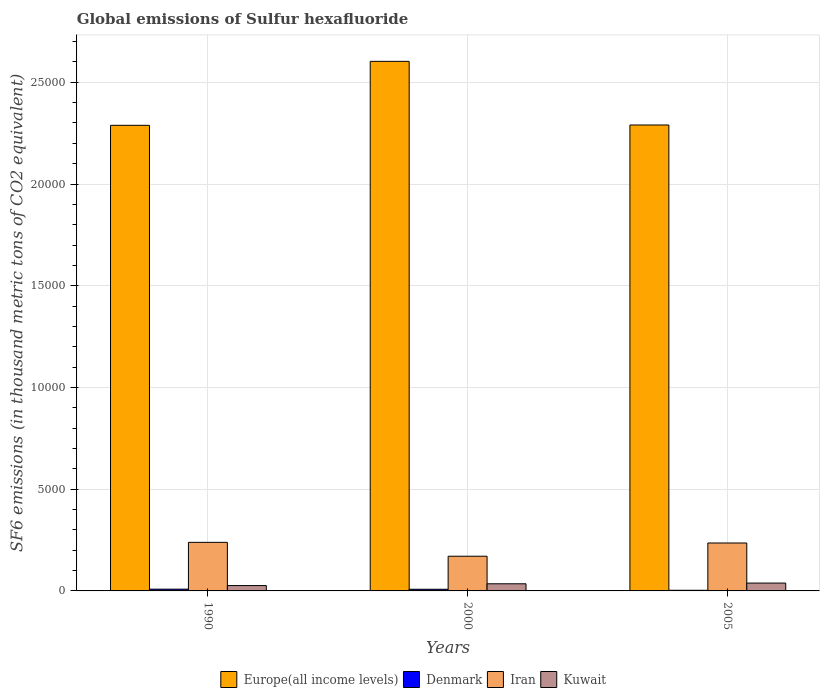Are the number of bars per tick equal to the number of legend labels?
Give a very brief answer. Yes. What is the global emissions of Sulfur hexafluoride in Iran in 1990?
Your answer should be compact. 2387.3. Across all years, what is the maximum global emissions of Sulfur hexafluoride in Europe(all income levels)?
Your answer should be compact. 2.60e+04. Across all years, what is the minimum global emissions of Sulfur hexafluoride in Denmark?
Your answer should be compact. 31.5. In which year was the global emissions of Sulfur hexafluoride in Denmark minimum?
Offer a terse response. 2005. What is the total global emissions of Sulfur hexafluoride in Denmark in the graph?
Provide a succinct answer. 199.6. What is the difference between the global emissions of Sulfur hexafluoride in Denmark in 1990 and that in 2005?
Keep it short and to the point. 55.2. What is the difference between the global emissions of Sulfur hexafluoride in Kuwait in 2000 and the global emissions of Sulfur hexafluoride in Iran in 1990?
Make the answer very short. -2036.4. What is the average global emissions of Sulfur hexafluoride in Iran per year?
Your response must be concise. 2149.23. In the year 2000, what is the difference between the global emissions of Sulfur hexafluoride in Kuwait and global emissions of Sulfur hexafluoride in Iran?
Provide a short and direct response. -1354. In how many years, is the global emissions of Sulfur hexafluoride in Europe(all income levels) greater than 7000 thousand metric tons?
Provide a succinct answer. 3. What is the ratio of the global emissions of Sulfur hexafluoride in Denmark in 2000 to that in 2005?
Provide a short and direct response. 2.58. Is the global emissions of Sulfur hexafluoride in Denmark in 2000 less than that in 2005?
Offer a very short reply. No. Is the difference between the global emissions of Sulfur hexafluoride in Kuwait in 2000 and 2005 greater than the difference between the global emissions of Sulfur hexafluoride in Iran in 2000 and 2005?
Provide a short and direct response. Yes. What is the difference between the highest and the second highest global emissions of Sulfur hexafluoride in Iran?
Give a very brief answer. 31.8. What is the difference between the highest and the lowest global emissions of Sulfur hexafluoride in Europe(all income levels)?
Offer a terse response. 3144.4. In how many years, is the global emissions of Sulfur hexafluoride in Iran greater than the average global emissions of Sulfur hexafluoride in Iran taken over all years?
Offer a terse response. 2. Is the sum of the global emissions of Sulfur hexafluoride in Iran in 1990 and 2000 greater than the maximum global emissions of Sulfur hexafluoride in Kuwait across all years?
Make the answer very short. Yes. What does the 2nd bar from the right in 2000 represents?
Your response must be concise. Iran. Is it the case that in every year, the sum of the global emissions of Sulfur hexafluoride in Kuwait and global emissions of Sulfur hexafluoride in Iran is greater than the global emissions of Sulfur hexafluoride in Europe(all income levels)?
Ensure brevity in your answer.  No. Are all the bars in the graph horizontal?
Make the answer very short. No. How many years are there in the graph?
Provide a short and direct response. 3. What is the difference between two consecutive major ticks on the Y-axis?
Keep it short and to the point. 5000. Are the values on the major ticks of Y-axis written in scientific E-notation?
Provide a short and direct response. No. Does the graph contain any zero values?
Ensure brevity in your answer.  No. How are the legend labels stacked?
Ensure brevity in your answer.  Horizontal. What is the title of the graph?
Ensure brevity in your answer.  Global emissions of Sulfur hexafluoride. Does "Middle East & North Africa (developing only)" appear as one of the legend labels in the graph?
Ensure brevity in your answer.  No. What is the label or title of the X-axis?
Provide a short and direct response. Years. What is the label or title of the Y-axis?
Your answer should be compact. SF6 emissions (in thousand metric tons of CO2 equivalent). What is the SF6 emissions (in thousand metric tons of CO2 equivalent) in Europe(all income levels) in 1990?
Ensure brevity in your answer.  2.29e+04. What is the SF6 emissions (in thousand metric tons of CO2 equivalent) of Denmark in 1990?
Provide a short and direct response. 86.7. What is the SF6 emissions (in thousand metric tons of CO2 equivalent) in Iran in 1990?
Give a very brief answer. 2387.3. What is the SF6 emissions (in thousand metric tons of CO2 equivalent) of Kuwait in 1990?
Give a very brief answer. 263. What is the SF6 emissions (in thousand metric tons of CO2 equivalent) in Europe(all income levels) in 2000?
Make the answer very short. 2.60e+04. What is the SF6 emissions (in thousand metric tons of CO2 equivalent) in Denmark in 2000?
Provide a short and direct response. 81.4. What is the SF6 emissions (in thousand metric tons of CO2 equivalent) of Iran in 2000?
Provide a succinct answer. 1704.9. What is the SF6 emissions (in thousand metric tons of CO2 equivalent) of Kuwait in 2000?
Give a very brief answer. 350.9. What is the SF6 emissions (in thousand metric tons of CO2 equivalent) of Europe(all income levels) in 2005?
Ensure brevity in your answer.  2.29e+04. What is the SF6 emissions (in thousand metric tons of CO2 equivalent) in Denmark in 2005?
Your answer should be very brief. 31.5. What is the SF6 emissions (in thousand metric tons of CO2 equivalent) of Iran in 2005?
Your answer should be compact. 2355.5. What is the SF6 emissions (in thousand metric tons of CO2 equivalent) in Kuwait in 2005?
Make the answer very short. 386. Across all years, what is the maximum SF6 emissions (in thousand metric tons of CO2 equivalent) of Europe(all income levels)?
Your response must be concise. 2.60e+04. Across all years, what is the maximum SF6 emissions (in thousand metric tons of CO2 equivalent) of Denmark?
Your answer should be compact. 86.7. Across all years, what is the maximum SF6 emissions (in thousand metric tons of CO2 equivalent) in Iran?
Offer a very short reply. 2387.3. Across all years, what is the maximum SF6 emissions (in thousand metric tons of CO2 equivalent) of Kuwait?
Provide a short and direct response. 386. Across all years, what is the minimum SF6 emissions (in thousand metric tons of CO2 equivalent) of Europe(all income levels)?
Provide a short and direct response. 2.29e+04. Across all years, what is the minimum SF6 emissions (in thousand metric tons of CO2 equivalent) of Denmark?
Provide a short and direct response. 31.5. Across all years, what is the minimum SF6 emissions (in thousand metric tons of CO2 equivalent) in Iran?
Your response must be concise. 1704.9. Across all years, what is the minimum SF6 emissions (in thousand metric tons of CO2 equivalent) in Kuwait?
Make the answer very short. 263. What is the total SF6 emissions (in thousand metric tons of CO2 equivalent) of Europe(all income levels) in the graph?
Offer a terse response. 7.18e+04. What is the total SF6 emissions (in thousand metric tons of CO2 equivalent) in Denmark in the graph?
Keep it short and to the point. 199.6. What is the total SF6 emissions (in thousand metric tons of CO2 equivalent) of Iran in the graph?
Give a very brief answer. 6447.7. What is the total SF6 emissions (in thousand metric tons of CO2 equivalent) of Kuwait in the graph?
Your response must be concise. 999.9. What is the difference between the SF6 emissions (in thousand metric tons of CO2 equivalent) of Europe(all income levels) in 1990 and that in 2000?
Provide a short and direct response. -3144.4. What is the difference between the SF6 emissions (in thousand metric tons of CO2 equivalent) of Denmark in 1990 and that in 2000?
Offer a very short reply. 5.3. What is the difference between the SF6 emissions (in thousand metric tons of CO2 equivalent) of Iran in 1990 and that in 2000?
Ensure brevity in your answer.  682.4. What is the difference between the SF6 emissions (in thousand metric tons of CO2 equivalent) of Kuwait in 1990 and that in 2000?
Offer a very short reply. -87.9. What is the difference between the SF6 emissions (in thousand metric tons of CO2 equivalent) of Europe(all income levels) in 1990 and that in 2005?
Your response must be concise. -16.51. What is the difference between the SF6 emissions (in thousand metric tons of CO2 equivalent) in Denmark in 1990 and that in 2005?
Give a very brief answer. 55.2. What is the difference between the SF6 emissions (in thousand metric tons of CO2 equivalent) in Iran in 1990 and that in 2005?
Your answer should be very brief. 31.8. What is the difference between the SF6 emissions (in thousand metric tons of CO2 equivalent) of Kuwait in 1990 and that in 2005?
Offer a terse response. -123. What is the difference between the SF6 emissions (in thousand metric tons of CO2 equivalent) of Europe(all income levels) in 2000 and that in 2005?
Ensure brevity in your answer.  3127.89. What is the difference between the SF6 emissions (in thousand metric tons of CO2 equivalent) of Denmark in 2000 and that in 2005?
Offer a very short reply. 49.9. What is the difference between the SF6 emissions (in thousand metric tons of CO2 equivalent) of Iran in 2000 and that in 2005?
Your answer should be compact. -650.6. What is the difference between the SF6 emissions (in thousand metric tons of CO2 equivalent) in Kuwait in 2000 and that in 2005?
Give a very brief answer. -35.1. What is the difference between the SF6 emissions (in thousand metric tons of CO2 equivalent) of Europe(all income levels) in 1990 and the SF6 emissions (in thousand metric tons of CO2 equivalent) of Denmark in 2000?
Your answer should be compact. 2.28e+04. What is the difference between the SF6 emissions (in thousand metric tons of CO2 equivalent) of Europe(all income levels) in 1990 and the SF6 emissions (in thousand metric tons of CO2 equivalent) of Iran in 2000?
Offer a very short reply. 2.12e+04. What is the difference between the SF6 emissions (in thousand metric tons of CO2 equivalent) of Europe(all income levels) in 1990 and the SF6 emissions (in thousand metric tons of CO2 equivalent) of Kuwait in 2000?
Your response must be concise. 2.25e+04. What is the difference between the SF6 emissions (in thousand metric tons of CO2 equivalent) of Denmark in 1990 and the SF6 emissions (in thousand metric tons of CO2 equivalent) of Iran in 2000?
Your response must be concise. -1618.2. What is the difference between the SF6 emissions (in thousand metric tons of CO2 equivalent) in Denmark in 1990 and the SF6 emissions (in thousand metric tons of CO2 equivalent) in Kuwait in 2000?
Give a very brief answer. -264.2. What is the difference between the SF6 emissions (in thousand metric tons of CO2 equivalent) of Iran in 1990 and the SF6 emissions (in thousand metric tons of CO2 equivalent) of Kuwait in 2000?
Offer a terse response. 2036.4. What is the difference between the SF6 emissions (in thousand metric tons of CO2 equivalent) of Europe(all income levels) in 1990 and the SF6 emissions (in thousand metric tons of CO2 equivalent) of Denmark in 2005?
Give a very brief answer. 2.29e+04. What is the difference between the SF6 emissions (in thousand metric tons of CO2 equivalent) of Europe(all income levels) in 1990 and the SF6 emissions (in thousand metric tons of CO2 equivalent) of Iran in 2005?
Your answer should be very brief. 2.05e+04. What is the difference between the SF6 emissions (in thousand metric tons of CO2 equivalent) in Europe(all income levels) in 1990 and the SF6 emissions (in thousand metric tons of CO2 equivalent) in Kuwait in 2005?
Provide a short and direct response. 2.25e+04. What is the difference between the SF6 emissions (in thousand metric tons of CO2 equivalent) of Denmark in 1990 and the SF6 emissions (in thousand metric tons of CO2 equivalent) of Iran in 2005?
Keep it short and to the point. -2268.8. What is the difference between the SF6 emissions (in thousand metric tons of CO2 equivalent) in Denmark in 1990 and the SF6 emissions (in thousand metric tons of CO2 equivalent) in Kuwait in 2005?
Ensure brevity in your answer.  -299.3. What is the difference between the SF6 emissions (in thousand metric tons of CO2 equivalent) in Iran in 1990 and the SF6 emissions (in thousand metric tons of CO2 equivalent) in Kuwait in 2005?
Keep it short and to the point. 2001.3. What is the difference between the SF6 emissions (in thousand metric tons of CO2 equivalent) of Europe(all income levels) in 2000 and the SF6 emissions (in thousand metric tons of CO2 equivalent) of Denmark in 2005?
Your answer should be compact. 2.60e+04. What is the difference between the SF6 emissions (in thousand metric tons of CO2 equivalent) in Europe(all income levels) in 2000 and the SF6 emissions (in thousand metric tons of CO2 equivalent) in Iran in 2005?
Your answer should be very brief. 2.37e+04. What is the difference between the SF6 emissions (in thousand metric tons of CO2 equivalent) of Europe(all income levels) in 2000 and the SF6 emissions (in thousand metric tons of CO2 equivalent) of Kuwait in 2005?
Your answer should be compact. 2.56e+04. What is the difference between the SF6 emissions (in thousand metric tons of CO2 equivalent) of Denmark in 2000 and the SF6 emissions (in thousand metric tons of CO2 equivalent) of Iran in 2005?
Your response must be concise. -2274.1. What is the difference between the SF6 emissions (in thousand metric tons of CO2 equivalent) in Denmark in 2000 and the SF6 emissions (in thousand metric tons of CO2 equivalent) in Kuwait in 2005?
Your response must be concise. -304.6. What is the difference between the SF6 emissions (in thousand metric tons of CO2 equivalent) in Iran in 2000 and the SF6 emissions (in thousand metric tons of CO2 equivalent) in Kuwait in 2005?
Your answer should be compact. 1318.9. What is the average SF6 emissions (in thousand metric tons of CO2 equivalent) in Europe(all income levels) per year?
Your answer should be very brief. 2.39e+04. What is the average SF6 emissions (in thousand metric tons of CO2 equivalent) in Denmark per year?
Offer a terse response. 66.53. What is the average SF6 emissions (in thousand metric tons of CO2 equivalent) of Iran per year?
Keep it short and to the point. 2149.23. What is the average SF6 emissions (in thousand metric tons of CO2 equivalent) in Kuwait per year?
Your answer should be compact. 333.3. In the year 1990, what is the difference between the SF6 emissions (in thousand metric tons of CO2 equivalent) in Europe(all income levels) and SF6 emissions (in thousand metric tons of CO2 equivalent) in Denmark?
Provide a short and direct response. 2.28e+04. In the year 1990, what is the difference between the SF6 emissions (in thousand metric tons of CO2 equivalent) in Europe(all income levels) and SF6 emissions (in thousand metric tons of CO2 equivalent) in Iran?
Your response must be concise. 2.05e+04. In the year 1990, what is the difference between the SF6 emissions (in thousand metric tons of CO2 equivalent) in Europe(all income levels) and SF6 emissions (in thousand metric tons of CO2 equivalent) in Kuwait?
Make the answer very short. 2.26e+04. In the year 1990, what is the difference between the SF6 emissions (in thousand metric tons of CO2 equivalent) in Denmark and SF6 emissions (in thousand metric tons of CO2 equivalent) in Iran?
Your answer should be compact. -2300.6. In the year 1990, what is the difference between the SF6 emissions (in thousand metric tons of CO2 equivalent) in Denmark and SF6 emissions (in thousand metric tons of CO2 equivalent) in Kuwait?
Keep it short and to the point. -176.3. In the year 1990, what is the difference between the SF6 emissions (in thousand metric tons of CO2 equivalent) in Iran and SF6 emissions (in thousand metric tons of CO2 equivalent) in Kuwait?
Ensure brevity in your answer.  2124.3. In the year 2000, what is the difference between the SF6 emissions (in thousand metric tons of CO2 equivalent) in Europe(all income levels) and SF6 emissions (in thousand metric tons of CO2 equivalent) in Denmark?
Your response must be concise. 2.59e+04. In the year 2000, what is the difference between the SF6 emissions (in thousand metric tons of CO2 equivalent) in Europe(all income levels) and SF6 emissions (in thousand metric tons of CO2 equivalent) in Iran?
Keep it short and to the point. 2.43e+04. In the year 2000, what is the difference between the SF6 emissions (in thousand metric tons of CO2 equivalent) in Europe(all income levels) and SF6 emissions (in thousand metric tons of CO2 equivalent) in Kuwait?
Provide a short and direct response. 2.57e+04. In the year 2000, what is the difference between the SF6 emissions (in thousand metric tons of CO2 equivalent) in Denmark and SF6 emissions (in thousand metric tons of CO2 equivalent) in Iran?
Keep it short and to the point. -1623.5. In the year 2000, what is the difference between the SF6 emissions (in thousand metric tons of CO2 equivalent) in Denmark and SF6 emissions (in thousand metric tons of CO2 equivalent) in Kuwait?
Provide a succinct answer. -269.5. In the year 2000, what is the difference between the SF6 emissions (in thousand metric tons of CO2 equivalent) of Iran and SF6 emissions (in thousand metric tons of CO2 equivalent) of Kuwait?
Provide a succinct answer. 1354. In the year 2005, what is the difference between the SF6 emissions (in thousand metric tons of CO2 equivalent) of Europe(all income levels) and SF6 emissions (in thousand metric tons of CO2 equivalent) of Denmark?
Provide a short and direct response. 2.29e+04. In the year 2005, what is the difference between the SF6 emissions (in thousand metric tons of CO2 equivalent) of Europe(all income levels) and SF6 emissions (in thousand metric tons of CO2 equivalent) of Iran?
Ensure brevity in your answer.  2.05e+04. In the year 2005, what is the difference between the SF6 emissions (in thousand metric tons of CO2 equivalent) in Europe(all income levels) and SF6 emissions (in thousand metric tons of CO2 equivalent) in Kuwait?
Your answer should be very brief. 2.25e+04. In the year 2005, what is the difference between the SF6 emissions (in thousand metric tons of CO2 equivalent) in Denmark and SF6 emissions (in thousand metric tons of CO2 equivalent) in Iran?
Offer a terse response. -2324. In the year 2005, what is the difference between the SF6 emissions (in thousand metric tons of CO2 equivalent) in Denmark and SF6 emissions (in thousand metric tons of CO2 equivalent) in Kuwait?
Provide a short and direct response. -354.5. In the year 2005, what is the difference between the SF6 emissions (in thousand metric tons of CO2 equivalent) of Iran and SF6 emissions (in thousand metric tons of CO2 equivalent) of Kuwait?
Make the answer very short. 1969.5. What is the ratio of the SF6 emissions (in thousand metric tons of CO2 equivalent) of Europe(all income levels) in 1990 to that in 2000?
Offer a terse response. 0.88. What is the ratio of the SF6 emissions (in thousand metric tons of CO2 equivalent) in Denmark in 1990 to that in 2000?
Your answer should be compact. 1.07. What is the ratio of the SF6 emissions (in thousand metric tons of CO2 equivalent) in Iran in 1990 to that in 2000?
Your answer should be compact. 1.4. What is the ratio of the SF6 emissions (in thousand metric tons of CO2 equivalent) of Kuwait in 1990 to that in 2000?
Provide a succinct answer. 0.75. What is the ratio of the SF6 emissions (in thousand metric tons of CO2 equivalent) of Europe(all income levels) in 1990 to that in 2005?
Make the answer very short. 1. What is the ratio of the SF6 emissions (in thousand metric tons of CO2 equivalent) in Denmark in 1990 to that in 2005?
Make the answer very short. 2.75. What is the ratio of the SF6 emissions (in thousand metric tons of CO2 equivalent) of Iran in 1990 to that in 2005?
Provide a short and direct response. 1.01. What is the ratio of the SF6 emissions (in thousand metric tons of CO2 equivalent) in Kuwait in 1990 to that in 2005?
Provide a short and direct response. 0.68. What is the ratio of the SF6 emissions (in thousand metric tons of CO2 equivalent) in Europe(all income levels) in 2000 to that in 2005?
Keep it short and to the point. 1.14. What is the ratio of the SF6 emissions (in thousand metric tons of CO2 equivalent) in Denmark in 2000 to that in 2005?
Offer a very short reply. 2.58. What is the ratio of the SF6 emissions (in thousand metric tons of CO2 equivalent) of Iran in 2000 to that in 2005?
Your response must be concise. 0.72. What is the difference between the highest and the second highest SF6 emissions (in thousand metric tons of CO2 equivalent) in Europe(all income levels)?
Your answer should be very brief. 3127.89. What is the difference between the highest and the second highest SF6 emissions (in thousand metric tons of CO2 equivalent) in Iran?
Your response must be concise. 31.8. What is the difference between the highest and the second highest SF6 emissions (in thousand metric tons of CO2 equivalent) in Kuwait?
Keep it short and to the point. 35.1. What is the difference between the highest and the lowest SF6 emissions (in thousand metric tons of CO2 equivalent) in Europe(all income levels)?
Offer a terse response. 3144.4. What is the difference between the highest and the lowest SF6 emissions (in thousand metric tons of CO2 equivalent) in Denmark?
Offer a terse response. 55.2. What is the difference between the highest and the lowest SF6 emissions (in thousand metric tons of CO2 equivalent) in Iran?
Keep it short and to the point. 682.4. What is the difference between the highest and the lowest SF6 emissions (in thousand metric tons of CO2 equivalent) in Kuwait?
Your answer should be very brief. 123. 